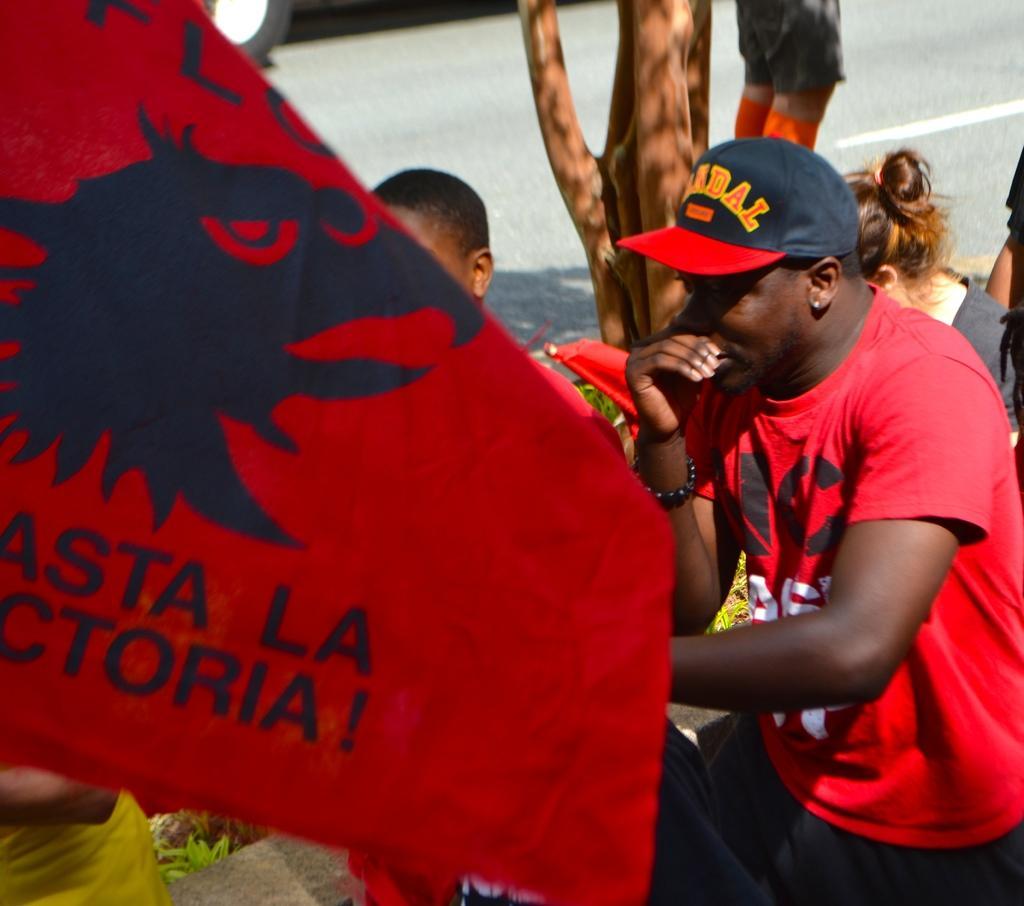In one or two sentences, can you explain what this image depicts? In this picture we can see some people in the front, on the left side it looks like a flag, we can see some text on the flag, a person on the right side wore a cap, there are plants at the bottom. 